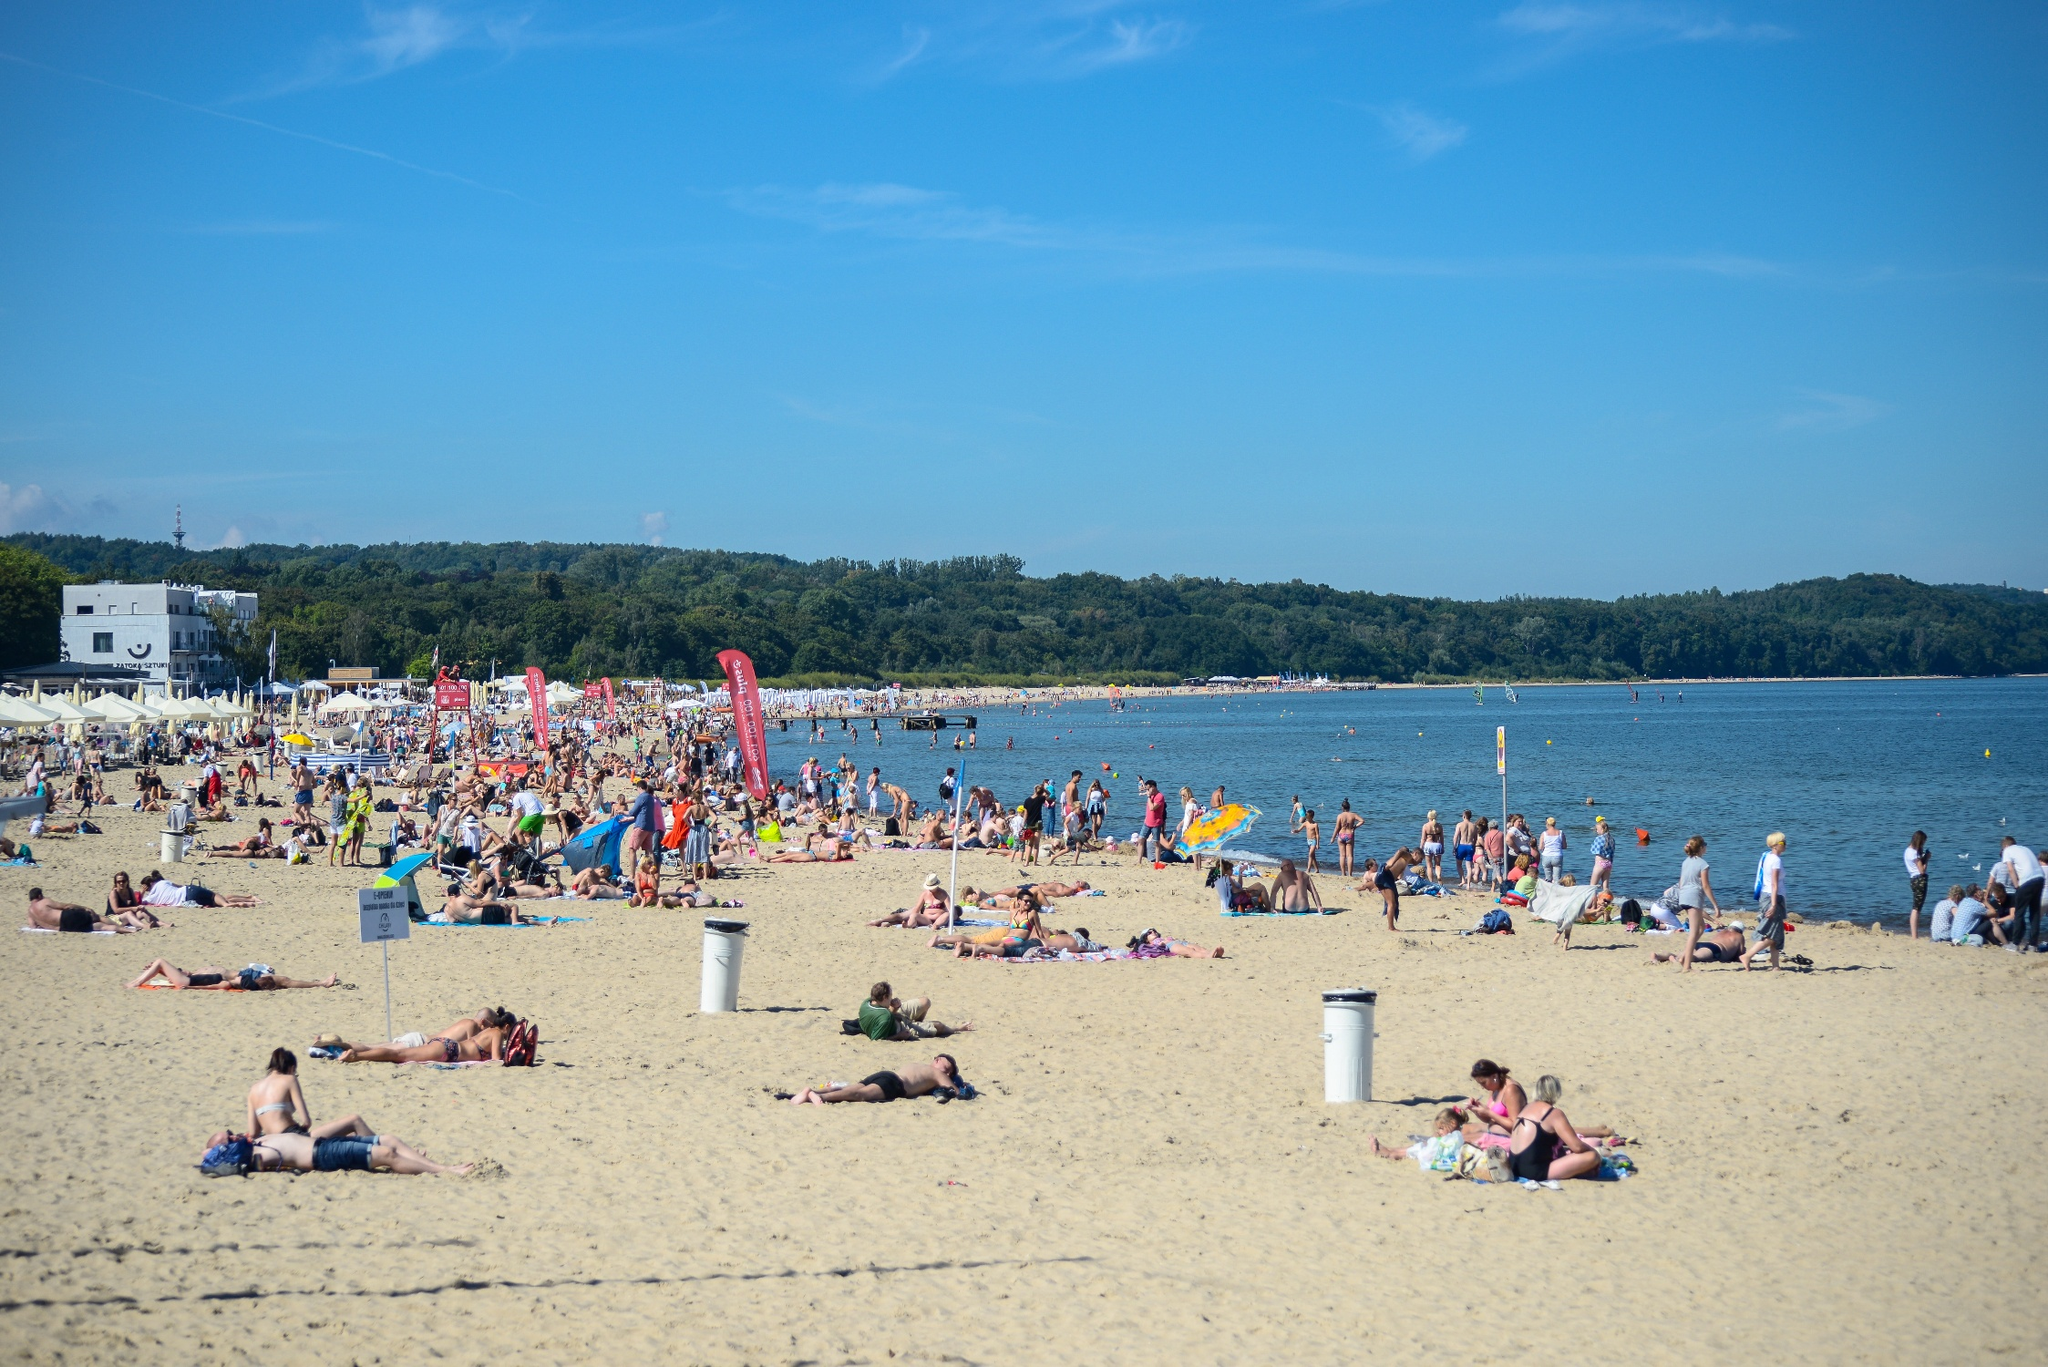Can you tell me about the different activities people are engaged in at the beach? Certainly! The beach is a mosaic of activities. Some visitors are lounging on beach towels or chairs, likely sunbathing or enjoying a good book. Others are more active, partaking in volleyball games or frisbee. A few are venturing into the water for a swim or a wade, while children seem preoccupied with sculpting sandcastles or chasing one another near the water's edge. You can also spot walkers and joggers taking advantage of the long stretch of sand for their exercise, all amidst the casual strollers who are there to breathe in the ocean air and perhaps snap a few memory-capturing photos. 